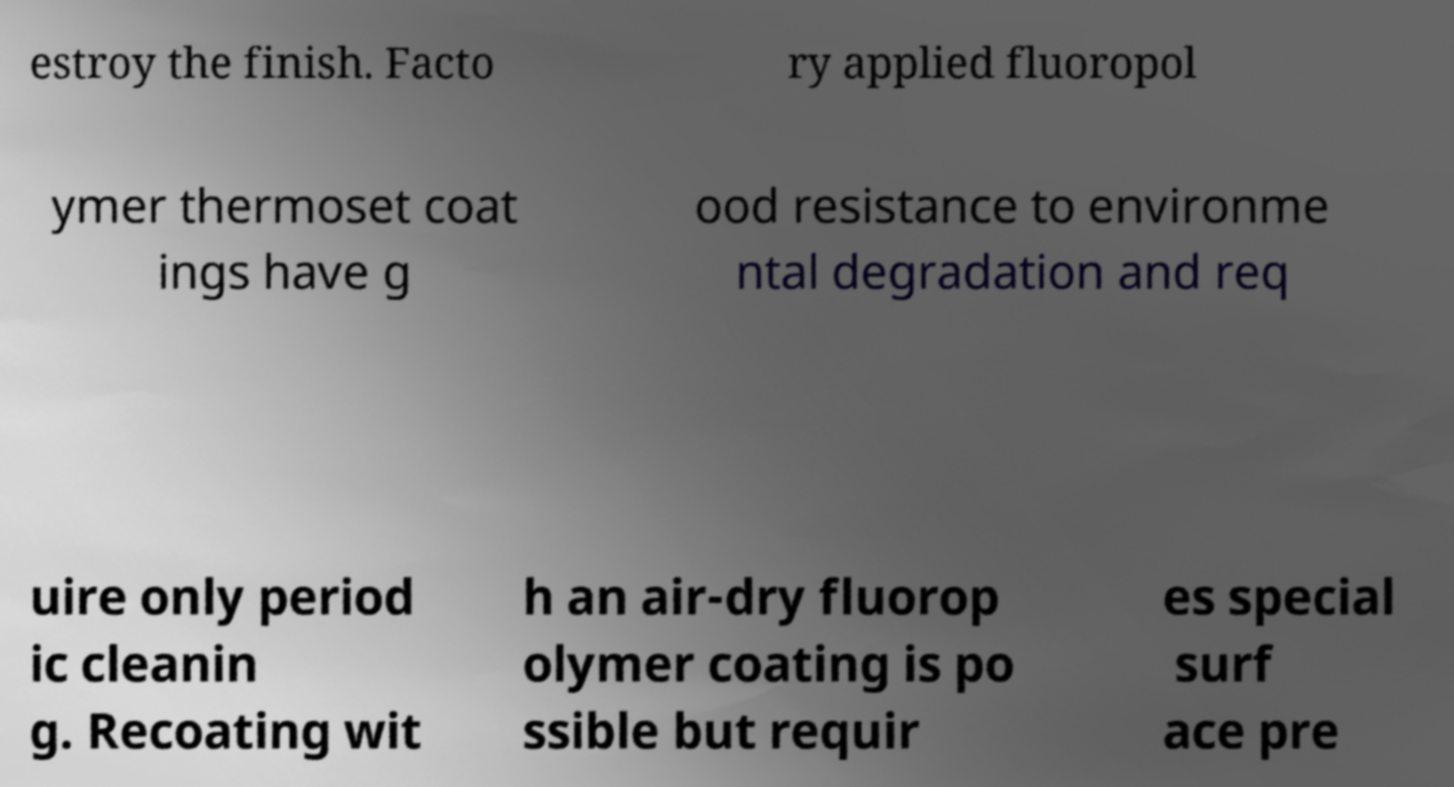Can you read and provide the text displayed in the image?This photo seems to have some interesting text. Can you extract and type it out for me? estroy the finish. Facto ry applied fluoropol ymer thermoset coat ings have g ood resistance to environme ntal degradation and req uire only period ic cleanin g. Recoating wit h an air-dry fluorop olymer coating is po ssible but requir es special surf ace pre 